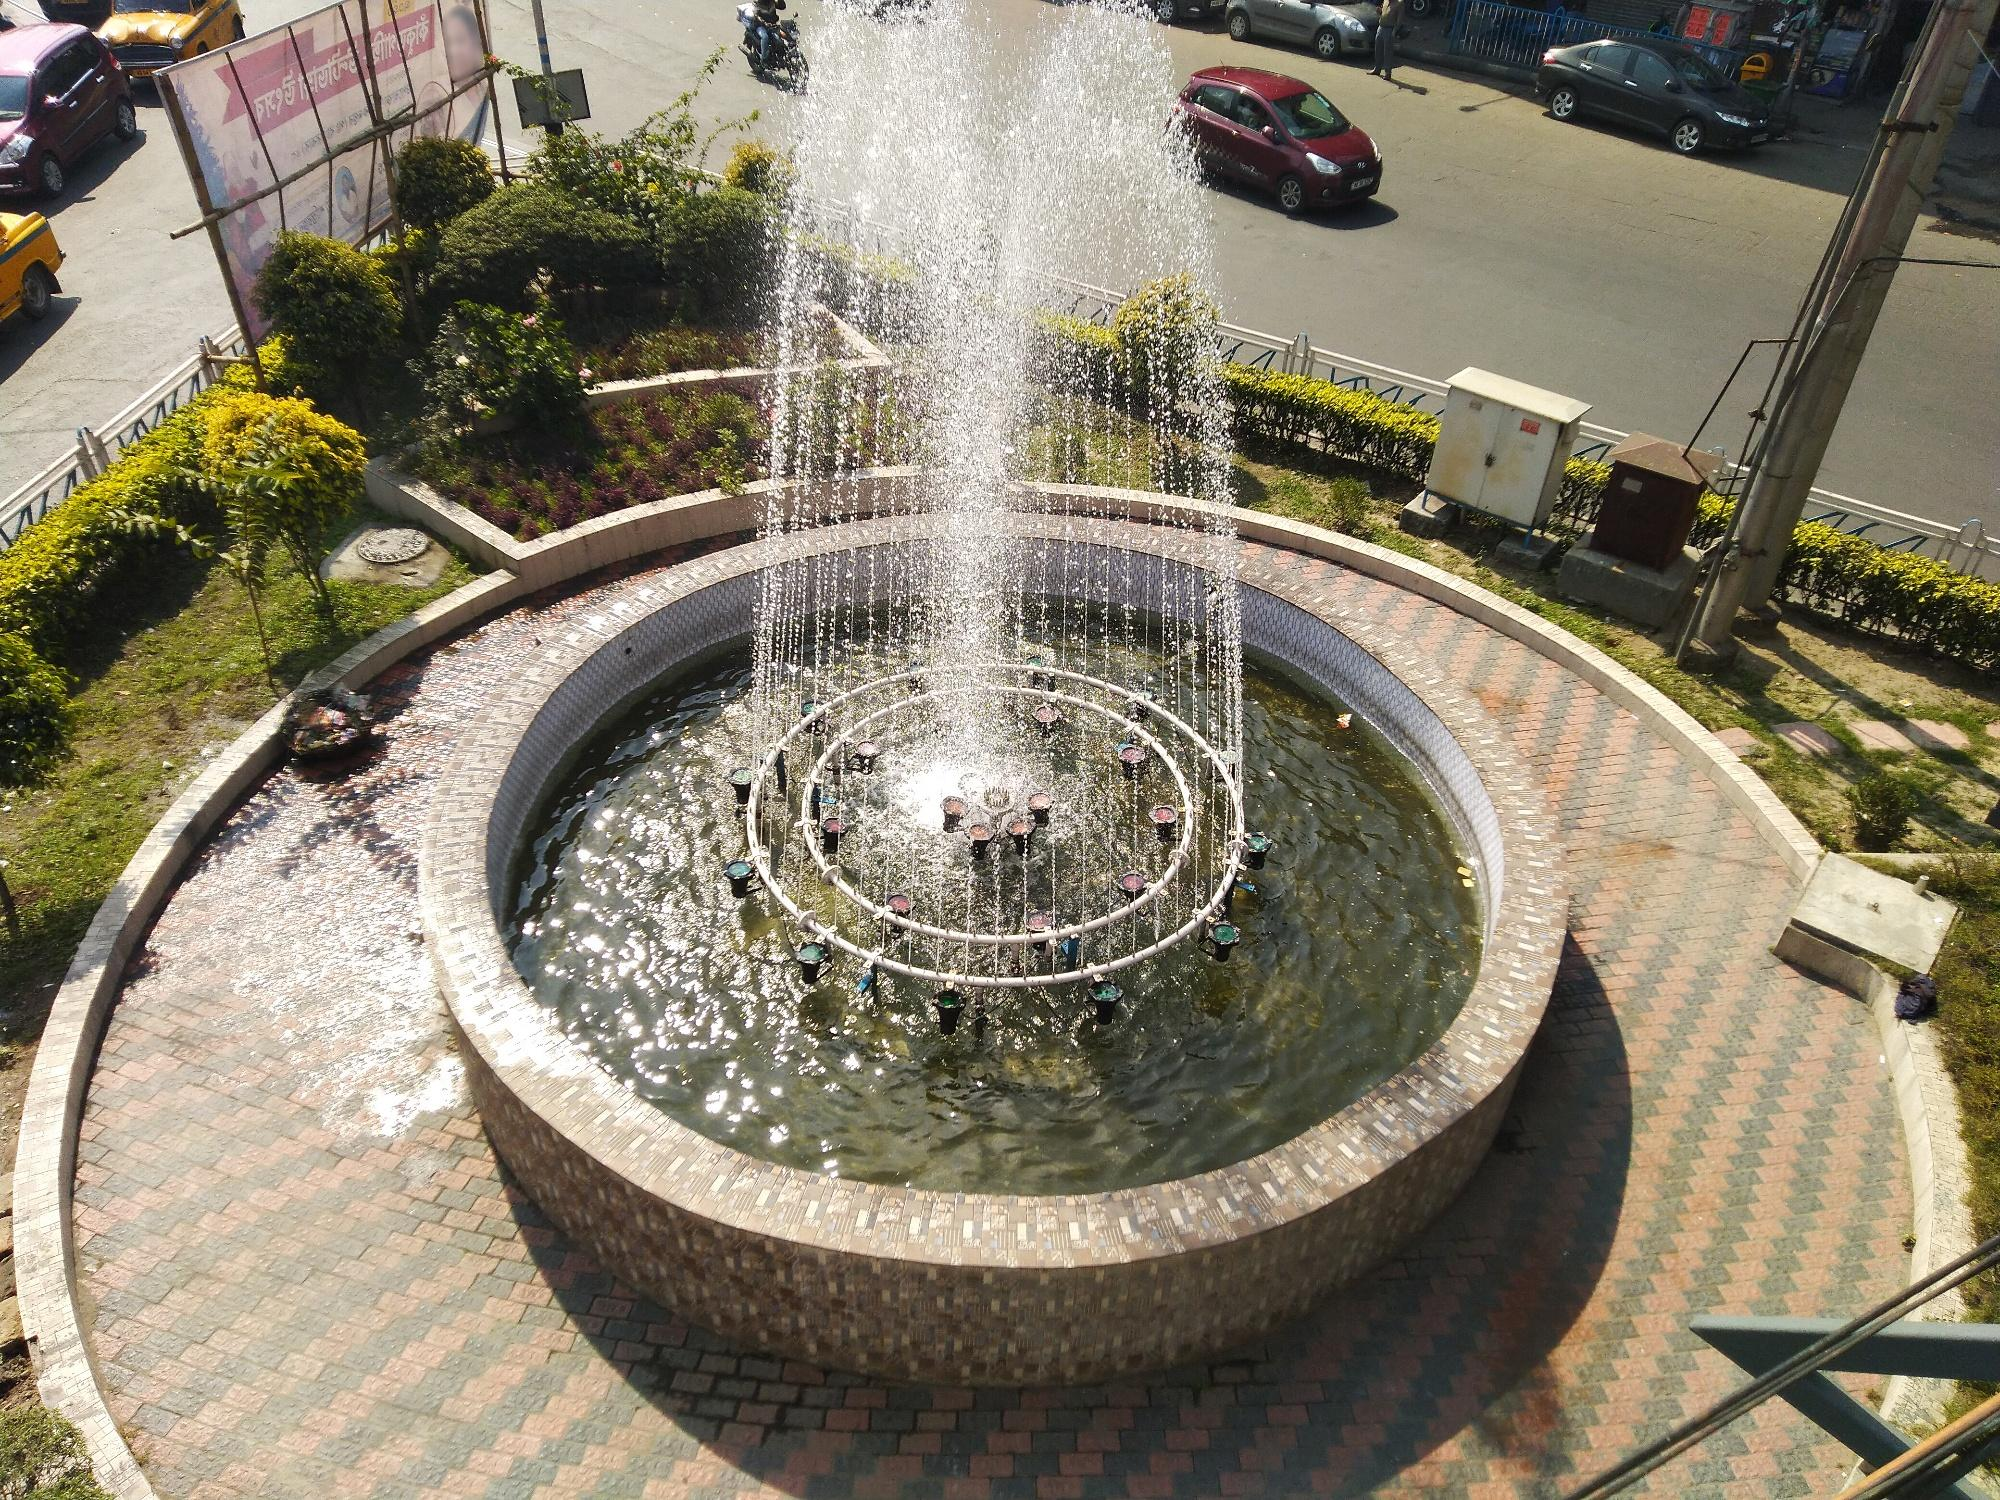Imagine a story where the fountain is a magical portal. What happens next? The fountain, under the stroke of dusk, begins to shimmer with an ethereal light. Suddenly, the water starts rotating faster, creating a vortex. Out of curiosity, a young girl steps closer, and the next thing she knows, she is pulled into another realm where mythical creatures and ancient forests await. The fountain was indeed a portal to a magical and adventurous world! 